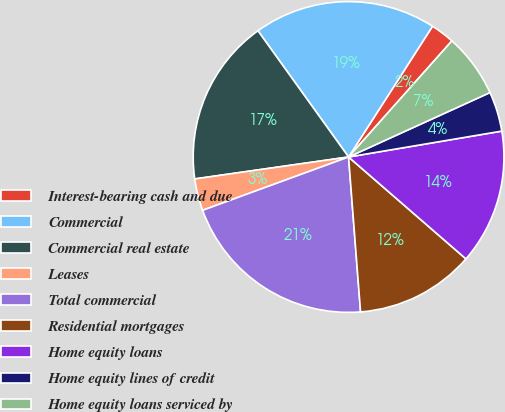Convert chart. <chart><loc_0><loc_0><loc_500><loc_500><pie_chart><fcel>Interest-bearing cash and due<fcel>Commercial<fcel>Commercial real estate<fcel>Leases<fcel>Total commercial<fcel>Residential mortgages<fcel>Home equity loans<fcel>Home equity lines of credit<fcel>Home equity loans serviced by<nl><fcel>2.49%<fcel>18.99%<fcel>17.34%<fcel>3.32%<fcel>20.65%<fcel>12.39%<fcel>14.04%<fcel>4.14%<fcel>6.62%<nl></chart> 